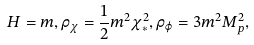<formula> <loc_0><loc_0><loc_500><loc_500>H = m , \rho _ { \chi } = \frac { 1 } { 2 } m ^ { 2 } \chi _ { * } ^ { 2 } , \rho _ { \varphi } = 3 m ^ { 2 } M _ { p } ^ { 2 } ,</formula> 